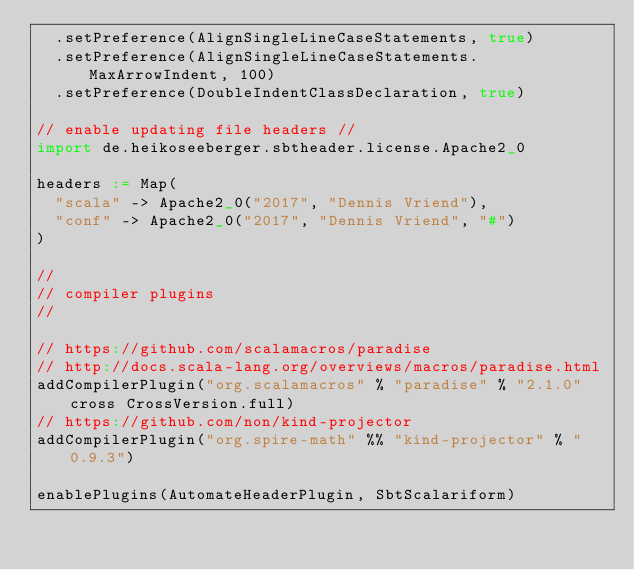Convert code to text. <code><loc_0><loc_0><loc_500><loc_500><_Scala_>  .setPreference(AlignSingleLineCaseStatements, true)
  .setPreference(AlignSingleLineCaseStatements.MaxArrowIndent, 100)
  .setPreference(DoubleIndentClassDeclaration, true)

// enable updating file headers //
import de.heikoseeberger.sbtheader.license.Apache2_0

headers := Map(
  "scala" -> Apache2_0("2017", "Dennis Vriend"),
  "conf" -> Apache2_0("2017", "Dennis Vriend", "#")
)

// 
// compiler plugins
//

// https://github.com/scalamacros/paradise
// http://docs.scala-lang.org/overviews/macros/paradise.html
addCompilerPlugin("org.scalamacros" % "paradise" % "2.1.0" cross CrossVersion.full)
// https://github.com/non/kind-projector
addCompilerPlugin("org.spire-math" %% "kind-projector" % "0.9.3")

enablePlugins(AutomateHeaderPlugin, SbtScalariform)
</code> 